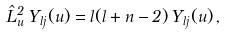Convert formula to latex. <formula><loc_0><loc_0><loc_500><loc_500>\hat { L } ^ { 2 } _ { u } \, Y _ { l j } ( u ) = l ( l + n - 2 ) \, Y _ { l j } ( u ) \, ,</formula> 